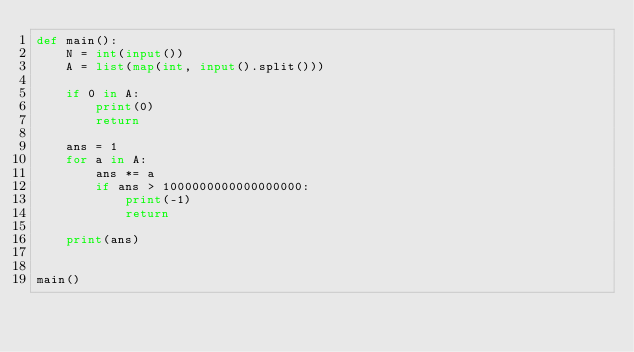<code> <loc_0><loc_0><loc_500><loc_500><_Python_>def main():
    N = int(input())
    A = list(map(int, input().split()))

    if 0 in A:
        print(0)
        return

    ans = 1
    for a in A:
        ans *= a
        if ans > 1000000000000000000:
            print(-1)
            return

    print(ans)


main()
</code> 